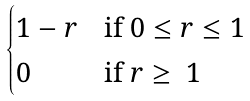<formula> <loc_0><loc_0><loc_500><loc_500>\begin{cases} 1 - r & \text {if $0\leq r \leq 1$} \\ 0 & \text {if $r\geq\ 1$} \\ \end{cases}</formula> 